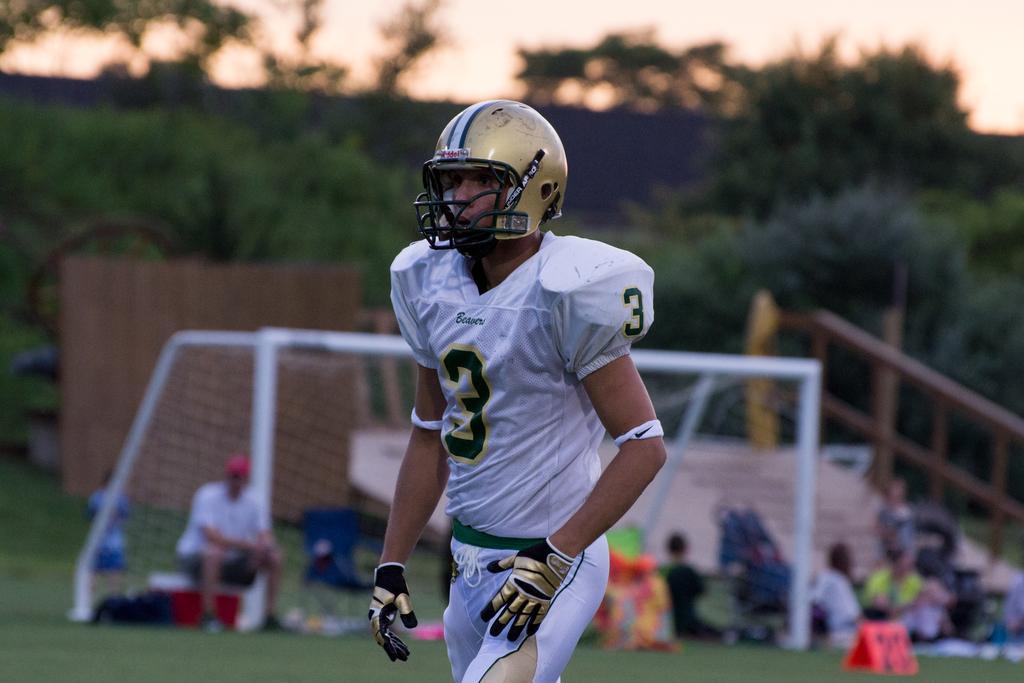Describe this image in one or two sentences. In the image we can see a man standing, wearing clothes, gloves and helmet. Here we can see net court, grass and there are other people sitting. Here we can see trees, sky and the background is blurred. 